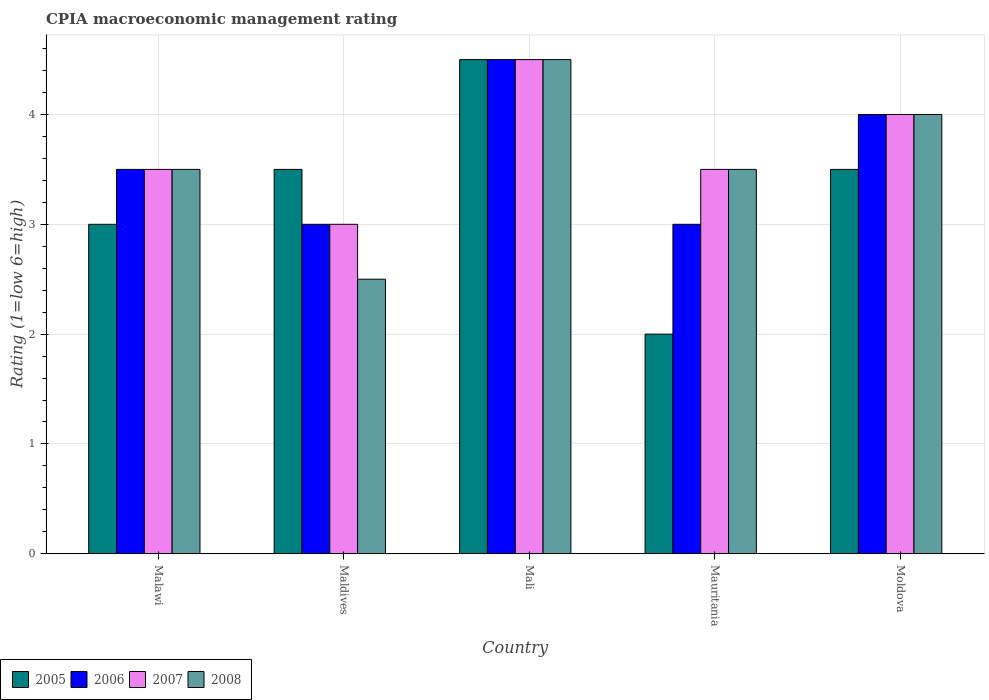How many different coloured bars are there?
Ensure brevity in your answer.  4. Are the number of bars per tick equal to the number of legend labels?
Provide a succinct answer. Yes. How many bars are there on the 4th tick from the right?
Your answer should be very brief. 4. What is the label of the 4th group of bars from the left?
Offer a terse response. Mauritania. In how many cases, is the number of bars for a given country not equal to the number of legend labels?
Offer a very short reply. 0. Across all countries, what is the maximum CPIA rating in 2007?
Provide a succinct answer. 4.5. Across all countries, what is the minimum CPIA rating in 2006?
Provide a succinct answer. 3. In which country was the CPIA rating in 2005 maximum?
Provide a short and direct response. Mali. In which country was the CPIA rating in 2007 minimum?
Your answer should be very brief. Maldives. What is the difference between the CPIA rating in 2005 in Mali and the CPIA rating in 2007 in Mauritania?
Your answer should be compact. 1. What is the average CPIA rating in 2006 per country?
Keep it short and to the point. 3.6. What is the difference between the CPIA rating of/in 2005 and CPIA rating of/in 2007 in Mali?
Make the answer very short. 0. Is the CPIA rating in 2007 in Malawi less than that in Moldova?
Keep it short and to the point. Yes. What is the difference between the highest and the second highest CPIA rating in 2008?
Offer a terse response. -1. In how many countries, is the CPIA rating in 2005 greater than the average CPIA rating in 2005 taken over all countries?
Keep it short and to the point. 3. What does the 3rd bar from the left in Malawi represents?
Your answer should be very brief. 2007. Is it the case that in every country, the sum of the CPIA rating in 2007 and CPIA rating in 2005 is greater than the CPIA rating in 2006?
Make the answer very short. Yes. Are all the bars in the graph horizontal?
Your answer should be very brief. No. How many countries are there in the graph?
Your answer should be compact. 5. Are the values on the major ticks of Y-axis written in scientific E-notation?
Give a very brief answer. No. How many legend labels are there?
Provide a succinct answer. 4. What is the title of the graph?
Make the answer very short. CPIA macroeconomic management rating. What is the Rating (1=low 6=high) in 2006 in Malawi?
Your answer should be compact. 3.5. What is the Rating (1=low 6=high) of 2007 in Malawi?
Ensure brevity in your answer.  3.5. What is the Rating (1=low 6=high) in 2008 in Maldives?
Ensure brevity in your answer.  2.5. What is the Rating (1=low 6=high) of 2005 in Mali?
Your answer should be compact. 4.5. What is the Rating (1=low 6=high) in 2006 in Mali?
Give a very brief answer. 4.5. What is the Rating (1=low 6=high) of 2008 in Mauritania?
Your answer should be very brief. 3.5. What is the Rating (1=low 6=high) in 2007 in Moldova?
Your answer should be very brief. 4. What is the Rating (1=low 6=high) in 2008 in Moldova?
Provide a succinct answer. 4. Across all countries, what is the maximum Rating (1=low 6=high) of 2007?
Your answer should be very brief. 4.5. Across all countries, what is the minimum Rating (1=low 6=high) of 2006?
Your response must be concise. 3. What is the total Rating (1=low 6=high) of 2005 in the graph?
Your response must be concise. 16.5. What is the total Rating (1=low 6=high) in 2008 in the graph?
Your response must be concise. 18. What is the difference between the Rating (1=low 6=high) of 2005 in Malawi and that in Mali?
Provide a short and direct response. -1.5. What is the difference between the Rating (1=low 6=high) of 2006 in Malawi and that in Mali?
Offer a terse response. -1. What is the difference between the Rating (1=low 6=high) of 2007 in Malawi and that in Mali?
Make the answer very short. -1. What is the difference between the Rating (1=low 6=high) of 2008 in Malawi and that in Mali?
Provide a short and direct response. -1. What is the difference between the Rating (1=low 6=high) of 2005 in Malawi and that in Moldova?
Provide a succinct answer. -0.5. What is the difference between the Rating (1=low 6=high) of 2006 in Malawi and that in Moldova?
Keep it short and to the point. -0.5. What is the difference between the Rating (1=low 6=high) of 2007 in Malawi and that in Moldova?
Provide a succinct answer. -0.5. What is the difference between the Rating (1=low 6=high) of 2008 in Malawi and that in Moldova?
Keep it short and to the point. -0.5. What is the difference between the Rating (1=low 6=high) of 2005 in Maldives and that in Mali?
Provide a short and direct response. -1. What is the difference between the Rating (1=low 6=high) of 2006 in Maldives and that in Mali?
Make the answer very short. -1.5. What is the difference between the Rating (1=low 6=high) of 2007 in Maldives and that in Mauritania?
Your answer should be compact. -0.5. What is the difference between the Rating (1=low 6=high) of 2008 in Maldives and that in Mauritania?
Offer a very short reply. -1. What is the difference between the Rating (1=low 6=high) in 2007 in Maldives and that in Moldova?
Your answer should be compact. -1. What is the difference between the Rating (1=low 6=high) in 2008 in Maldives and that in Moldova?
Keep it short and to the point. -1.5. What is the difference between the Rating (1=low 6=high) of 2006 in Mali and that in Mauritania?
Ensure brevity in your answer.  1.5. What is the difference between the Rating (1=low 6=high) in 2005 in Mali and that in Moldova?
Offer a terse response. 1. What is the difference between the Rating (1=low 6=high) in 2006 in Mali and that in Moldova?
Provide a succinct answer. 0.5. What is the difference between the Rating (1=low 6=high) of 2007 in Mali and that in Moldova?
Give a very brief answer. 0.5. What is the difference between the Rating (1=low 6=high) of 2008 in Mali and that in Moldova?
Offer a terse response. 0.5. What is the difference between the Rating (1=low 6=high) in 2005 in Mauritania and that in Moldova?
Your answer should be very brief. -1.5. What is the difference between the Rating (1=low 6=high) of 2006 in Mauritania and that in Moldova?
Ensure brevity in your answer.  -1. What is the difference between the Rating (1=low 6=high) of 2008 in Mauritania and that in Moldova?
Offer a very short reply. -0.5. What is the difference between the Rating (1=low 6=high) in 2005 in Malawi and the Rating (1=low 6=high) in 2007 in Maldives?
Ensure brevity in your answer.  0. What is the difference between the Rating (1=low 6=high) in 2006 in Malawi and the Rating (1=low 6=high) in 2007 in Maldives?
Your response must be concise. 0.5. What is the difference between the Rating (1=low 6=high) in 2006 in Malawi and the Rating (1=low 6=high) in 2008 in Maldives?
Offer a terse response. 1. What is the difference between the Rating (1=low 6=high) in 2005 in Malawi and the Rating (1=low 6=high) in 2008 in Mali?
Your answer should be compact. -1.5. What is the difference between the Rating (1=low 6=high) of 2005 in Malawi and the Rating (1=low 6=high) of 2006 in Mauritania?
Offer a very short reply. 0. What is the difference between the Rating (1=low 6=high) of 2005 in Malawi and the Rating (1=low 6=high) of 2007 in Mauritania?
Provide a succinct answer. -0.5. What is the difference between the Rating (1=low 6=high) of 2005 in Malawi and the Rating (1=low 6=high) of 2008 in Mauritania?
Offer a terse response. -0.5. What is the difference between the Rating (1=low 6=high) of 2007 in Malawi and the Rating (1=low 6=high) of 2008 in Mauritania?
Keep it short and to the point. 0. What is the difference between the Rating (1=low 6=high) in 2006 in Malawi and the Rating (1=low 6=high) in 2008 in Moldova?
Provide a succinct answer. -0.5. What is the difference between the Rating (1=low 6=high) in 2007 in Malawi and the Rating (1=low 6=high) in 2008 in Moldova?
Offer a very short reply. -0.5. What is the difference between the Rating (1=low 6=high) in 2005 in Maldives and the Rating (1=low 6=high) in 2007 in Mali?
Your answer should be compact. -1. What is the difference between the Rating (1=low 6=high) in 2005 in Maldives and the Rating (1=low 6=high) in 2008 in Mali?
Keep it short and to the point. -1. What is the difference between the Rating (1=low 6=high) in 2006 in Maldives and the Rating (1=low 6=high) in 2008 in Mali?
Your response must be concise. -1.5. What is the difference between the Rating (1=low 6=high) in 2005 in Maldives and the Rating (1=low 6=high) in 2006 in Mauritania?
Your response must be concise. 0.5. What is the difference between the Rating (1=low 6=high) of 2005 in Maldives and the Rating (1=low 6=high) of 2007 in Mauritania?
Offer a very short reply. 0. What is the difference between the Rating (1=low 6=high) of 2005 in Maldives and the Rating (1=low 6=high) of 2008 in Mauritania?
Keep it short and to the point. 0. What is the difference between the Rating (1=low 6=high) in 2006 in Maldives and the Rating (1=low 6=high) in 2007 in Mauritania?
Your answer should be compact. -0.5. What is the difference between the Rating (1=low 6=high) in 2005 in Maldives and the Rating (1=low 6=high) in 2006 in Moldova?
Offer a terse response. -0.5. What is the difference between the Rating (1=low 6=high) of 2005 in Maldives and the Rating (1=low 6=high) of 2008 in Moldova?
Give a very brief answer. -0.5. What is the difference between the Rating (1=low 6=high) of 2007 in Maldives and the Rating (1=low 6=high) of 2008 in Moldova?
Offer a terse response. -1. What is the difference between the Rating (1=low 6=high) in 2005 in Mali and the Rating (1=low 6=high) in 2007 in Mauritania?
Your answer should be compact. 1. What is the difference between the Rating (1=low 6=high) of 2005 in Mali and the Rating (1=low 6=high) of 2008 in Mauritania?
Offer a very short reply. 1. What is the difference between the Rating (1=low 6=high) of 2007 in Mali and the Rating (1=low 6=high) of 2008 in Mauritania?
Your answer should be very brief. 1. What is the difference between the Rating (1=low 6=high) of 2006 in Mali and the Rating (1=low 6=high) of 2007 in Moldova?
Your response must be concise. 0.5. What is the difference between the Rating (1=low 6=high) of 2007 in Mali and the Rating (1=low 6=high) of 2008 in Moldova?
Offer a terse response. 0.5. What is the difference between the Rating (1=low 6=high) of 2005 in Mauritania and the Rating (1=low 6=high) of 2007 in Moldova?
Make the answer very short. -2. What is the difference between the Rating (1=low 6=high) of 2005 in Mauritania and the Rating (1=low 6=high) of 2008 in Moldova?
Your answer should be very brief. -2. What is the difference between the Rating (1=low 6=high) of 2007 in Mauritania and the Rating (1=low 6=high) of 2008 in Moldova?
Your answer should be compact. -0.5. What is the average Rating (1=low 6=high) of 2006 per country?
Your answer should be very brief. 3.6. What is the average Rating (1=low 6=high) of 2007 per country?
Provide a short and direct response. 3.7. What is the difference between the Rating (1=low 6=high) of 2005 and Rating (1=low 6=high) of 2008 in Malawi?
Offer a very short reply. -0.5. What is the difference between the Rating (1=low 6=high) in 2006 and Rating (1=low 6=high) in 2007 in Malawi?
Provide a short and direct response. 0. What is the difference between the Rating (1=low 6=high) of 2006 and Rating (1=low 6=high) of 2008 in Malawi?
Ensure brevity in your answer.  0. What is the difference between the Rating (1=low 6=high) in 2007 and Rating (1=low 6=high) in 2008 in Malawi?
Your answer should be compact. 0. What is the difference between the Rating (1=low 6=high) of 2005 and Rating (1=low 6=high) of 2006 in Maldives?
Your answer should be compact. 0.5. What is the difference between the Rating (1=low 6=high) of 2005 and Rating (1=low 6=high) of 2007 in Maldives?
Your answer should be very brief. 0.5. What is the difference between the Rating (1=low 6=high) in 2006 and Rating (1=low 6=high) in 2007 in Maldives?
Provide a succinct answer. 0. What is the difference between the Rating (1=low 6=high) in 2006 and Rating (1=low 6=high) in 2008 in Maldives?
Your answer should be very brief. 0.5. What is the difference between the Rating (1=low 6=high) of 2007 and Rating (1=low 6=high) of 2008 in Maldives?
Your answer should be compact. 0.5. What is the difference between the Rating (1=low 6=high) in 2005 and Rating (1=low 6=high) in 2006 in Mali?
Your answer should be compact. 0. What is the difference between the Rating (1=low 6=high) in 2005 and Rating (1=low 6=high) in 2007 in Mali?
Make the answer very short. 0. What is the difference between the Rating (1=low 6=high) of 2005 and Rating (1=low 6=high) of 2008 in Mali?
Ensure brevity in your answer.  0. What is the difference between the Rating (1=low 6=high) in 2006 and Rating (1=low 6=high) in 2008 in Mali?
Provide a short and direct response. 0. What is the difference between the Rating (1=low 6=high) in 2006 and Rating (1=low 6=high) in 2007 in Mauritania?
Your answer should be very brief. -0.5. What is the difference between the Rating (1=low 6=high) in 2006 and Rating (1=low 6=high) in 2008 in Mauritania?
Keep it short and to the point. -0.5. What is the difference between the Rating (1=low 6=high) of 2005 and Rating (1=low 6=high) of 2006 in Moldova?
Provide a short and direct response. -0.5. What is the difference between the Rating (1=low 6=high) of 2005 and Rating (1=low 6=high) of 2007 in Moldova?
Ensure brevity in your answer.  -0.5. What is the difference between the Rating (1=low 6=high) in 2006 and Rating (1=low 6=high) in 2007 in Moldova?
Give a very brief answer. 0. What is the ratio of the Rating (1=low 6=high) in 2005 in Malawi to that in Maldives?
Make the answer very short. 0.86. What is the ratio of the Rating (1=low 6=high) in 2006 in Malawi to that in Maldives?
Offer a very short reply. 1.17. What is the ratio of the Rating (1=low 6=high) of 2008 in Malawi to that in Maldives?
Keep it short and to the point. 1.4. What is the ratio of the Rating (1=low 6=high) in 2005 in Malawi to that in Mali?
Make the answer very short. 0.67. What is the ratio of the Rating (1=low 6=high) of 2007 in Malawi to that in Mali?
Your answer should be compact. 0.78. What is the ratio of the Rating (1=low 6=high) of 2006 in Malawi to that in Mauritania?
Give a very brief answer. 1.17. What is the ratio of the Rating (1=low 6=high) of 2007 in Malawi to that in Mauritania?
Provide a succinct answer. 1. What is the ratio of the Rating (1=low 6=high) of 2008 in Malawi to that in Mauritania?
Offer a very short reply. 1. What is the ratio of the Rating (1=low 6=high) in 2006 in Malawi to that in Moldova?
Your response must be concise. 0.88. What is the ratio of the Rating (1=low 6=high) in 2007 in Malawi to that in Moldova?
Your answer should be compact. 0.88. What is the ratio of the Rating (1=low 6=high) of 2007 in Maldives to that in Mali?
Your response must be concise. 0.67. What is the ratio of the Rating (1=low 6=high) of 2008 in Maldives to that in Mali?
Your answer should be very brief. 0.56. What is the ratio of the Rating (1=low 6=high) in 2007 in Maldives to that in Mauritania?
Your answer should be very brief. 0.86. What is the ratio of the Rating (1=low 6=high) in 2008 in Maldives to that in Mauritania?
Provide a short and direct response. 0.71. What is the ratio of the Rating (1=low 6=high) in 2005 in Maldives to that in Moldova?
Keep it short and to the point. 1. What is the ratio of the Rating (1=low 6=high) in 2007 in Maldives to that in Moldova?
Your response must be concise. 0.75. What is the ratio of the Rating (1=low 6=high) of 2005 in Mali to that in Mauritania?
Offer a terse response. 2.25. What is the ratio of the Rating (1=low 6=high) in 2006 in Mali to that in Moldova?
Offer a very short reply. 1.12. What is the ratio of the Rating (1=low 6=high) in 2007 in Mauritania to that in Moldova?
Keep it short and to the point. 0.88. What is the ratio of the Rating (1=low 6=high) in 2008 in Mauritania to that in Moldova?
Your answer should be compact. 0.88. 